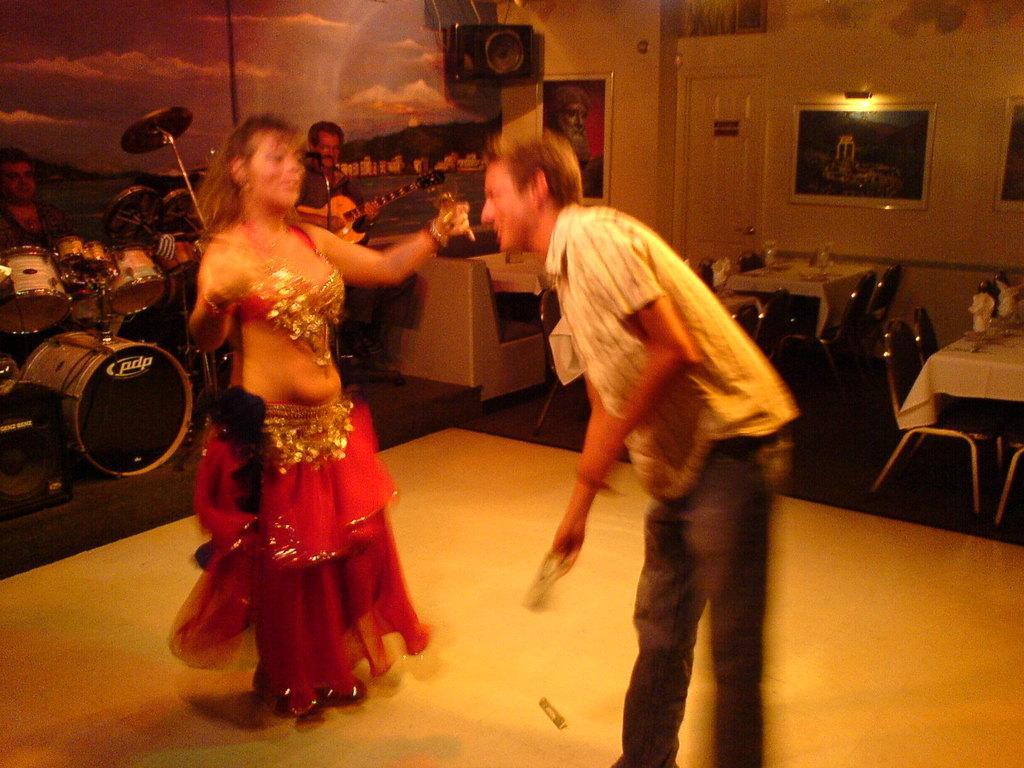Describe this image in one or two sentences. Here we can see two persons dancing on the floor. These are the tables and there are chairs. In the background there is a wall and these are the frames. This is door. Here we can see some musical instruments. And there is a sky. 